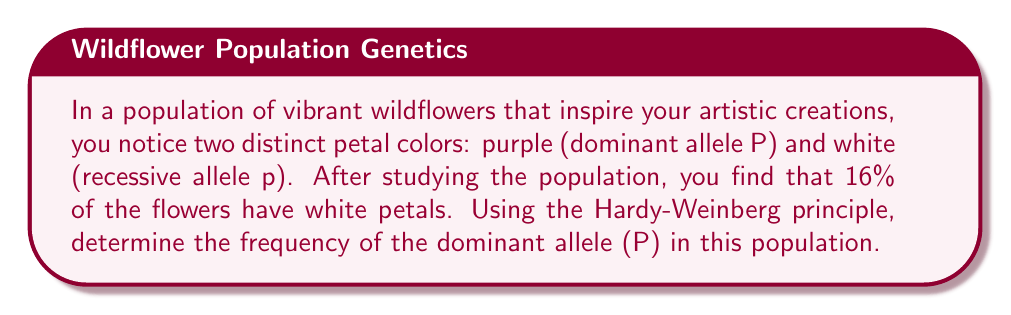What is the answer to this math problem? Let's approach this step-by-step using the Hardy-Weinberg principle:

1) First, recall the Hardy-Weinberg equation:
   $p^2 + 2pq + q^2 = 1$
   where $p$ is the frequency of the dominant allele, and $q$ is the frequency of the recessive allele.

2) We're told that 16% of the flowers have white petals. White petals are the recessive trait, so:
   $q^2 = 0.16$

3) To find $q$, we take the square root of both sides:
   $q = \sqrt{0.16} = 0.4$

4) Since $p + q = 1$ in the Hardy-Weinberg principle, we can find $p$:
   $p = 1 - q = 1 - 0.4 = 0.6$

5) Therefore, the frequency of the dominant allele (P) is 0.6 or 60%.

To verify:
$p^2 + 2pq + q^2 = (0.6)^2 + 2(0.6)(0.4) + (0.4)^2$
$= 0.36 + 0.48 + 0.16 = 1$

This confirms that our calculation satisfies the Hardy-Weinberg equilibrium.
Answer: The frequency of the dominant allele (P) in the population is 0.6 or 60%. 